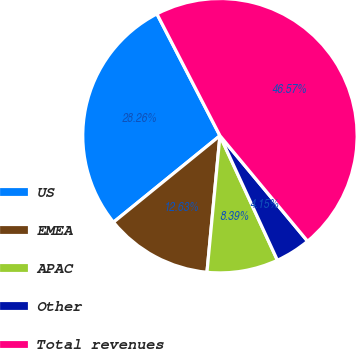Convert chart to OTSL. <chart><loc_0><loc_0><loc_500><loc_500><pie_chart><fcel>US<fcel>EMEA<fcel>APAC<fcel>Other<fcel>Total revenues<nl><fcel>28.26%<fcel>12.63%<fcel>8.39%<fcel>4.15%<fcel>46.57%<nl></chart> 